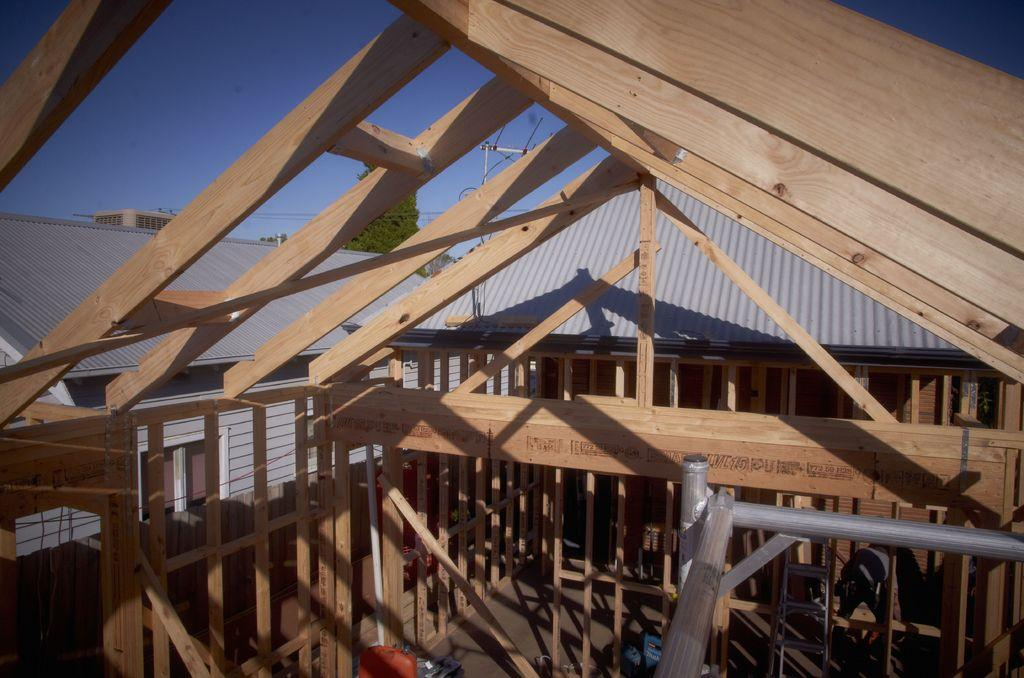What type of construction can be seen in the image? There is a wooden construction in the image. What color are the roofs of the buildings in the background? The roofs in the background are silver in color. What part of the natural environment is visible in the image? The sky is visible in the image. What type of marble is used in the construction of the authority's building in the image? There is no mention of marble or an authority's building in the image; it features a wooden construction and silver roofs in the background. Can you identify the wren that is perched on the roof of the wooden construction in the image? There is no wren present in the image. 